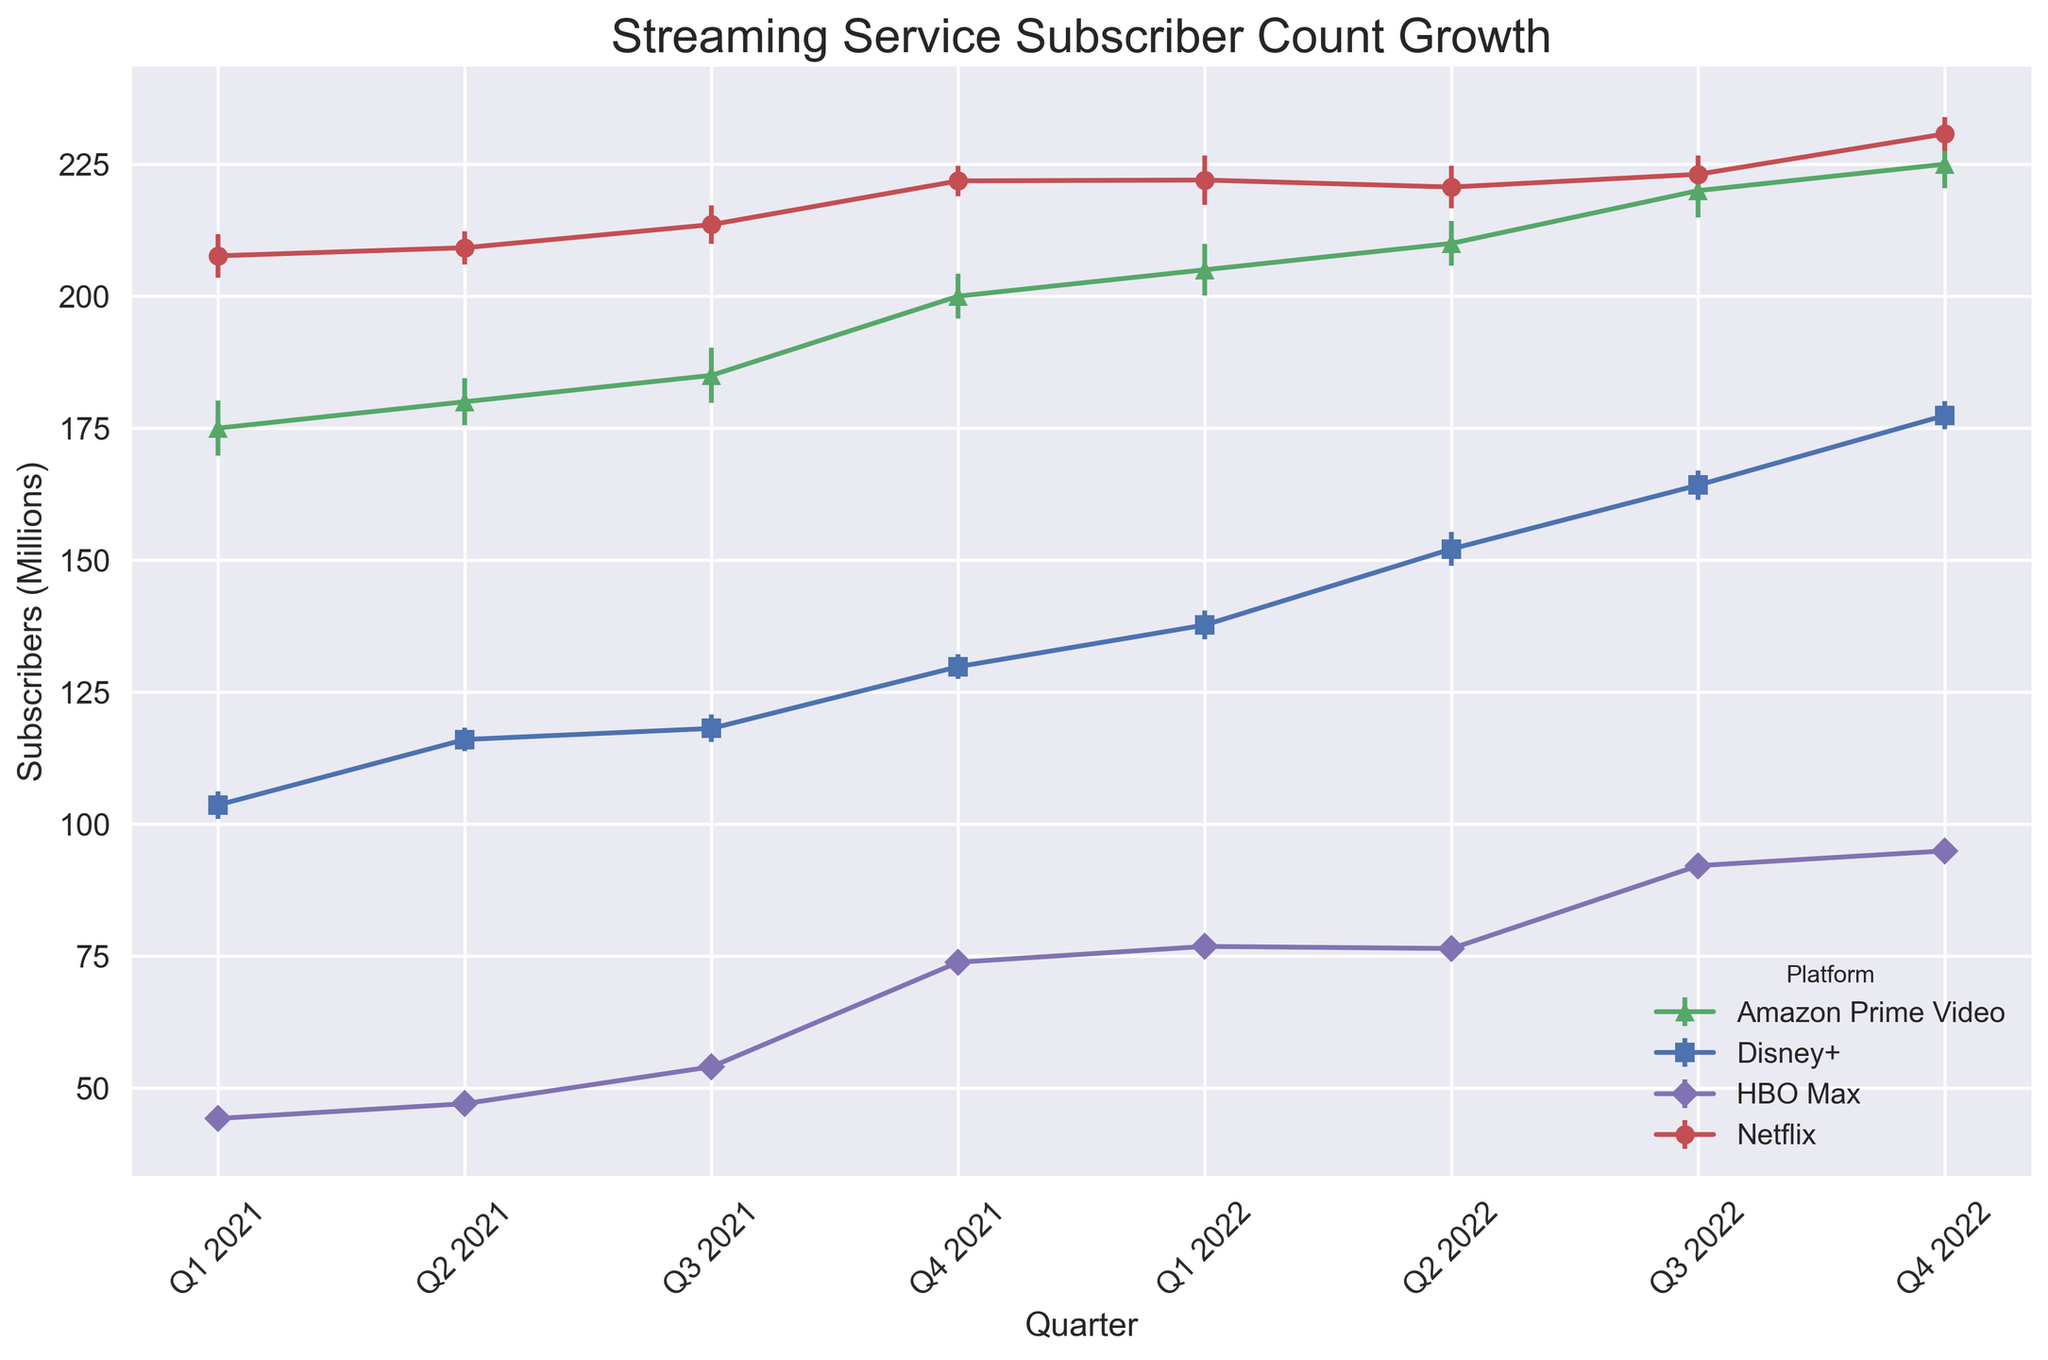Which streaming service had the highest subscriber count in Q4 2022? Looking at Q4 2022, Netflix had the highest subscriber count at 230.75 million.
Answer: Netflix What is the difference in subscriber count between Q1 2021 and Q4 2022 for Disney+? Disney+ had 103.6 million subscribers in Q1 2021 and 177.4 million in Q4 2022. The difference is 177.4 - 103.6 = 73.8 million.
Answer: 73.8 million Which platform experienced the largest error margin in Q1 2021, and what was the value? In Q1 2021, Amazon Prime Video had the largest error margin at 3%.
Answer: Amazon Prime Video What is the average subscriber count of Amazon Prime Video in 2022? The subscriber counts for the four quarters in 2022 for Amazon Prime Video are 205.0, 210.0, 220.0, and 225.0. The average is (205.0 + 210.0 + 220.0 + 225.0) / 4 = 215.0 million.
Answer: 215.0 million Which platform showed the most significant increase in subscriber count from Q2 2022 to Q3 2022, and what was the increase? HBO Max showed an increase from 76.4 million to 92.1 million. The increase is 92.1 - 76.4 = 15.7 million.
Answer: HBO Max, 15.7 million How many platforms exceeded 200 million subscribers in Q4 2022? Looking at Q4 2022, Netflix and Amazon Prime Video both exceeded 200 million subscribers (230.75 million and 225.0 million respectively).
Answer: 2 platforms Which platform has the smallest error margin in any quarter, and what is the value? In Q4 2022, Disney+ had the smallest error margin at 1.5%.
Answer: Disney+ Compare the subscriber growth from Q1 2021 to Q4 2021 for Netflix and HBO Max. Which grew more, and by how much? Netflix grew from 207.64 million to 221.84 million, an increase of 14.2 million. HBO Max grew from 44.2 million to 73.8 million, an increase of 29.6 million. HBO Max grew more by (29.6 - 14.2) = 15.4 million.
Answer: HBO Max, 15.4 million What was the total subscriber count for all platforms combined in Q4 2021? Adding up the Q4 2021 subscriber counts: Netflix (221.84), Disney+ (129.8), Amazon Prime Video (200.0), and HBO Max (73.8). Total = 221.84 + 129.8 + 200 + 73.8 = 625.44 million.
Answer: 625.44 million 